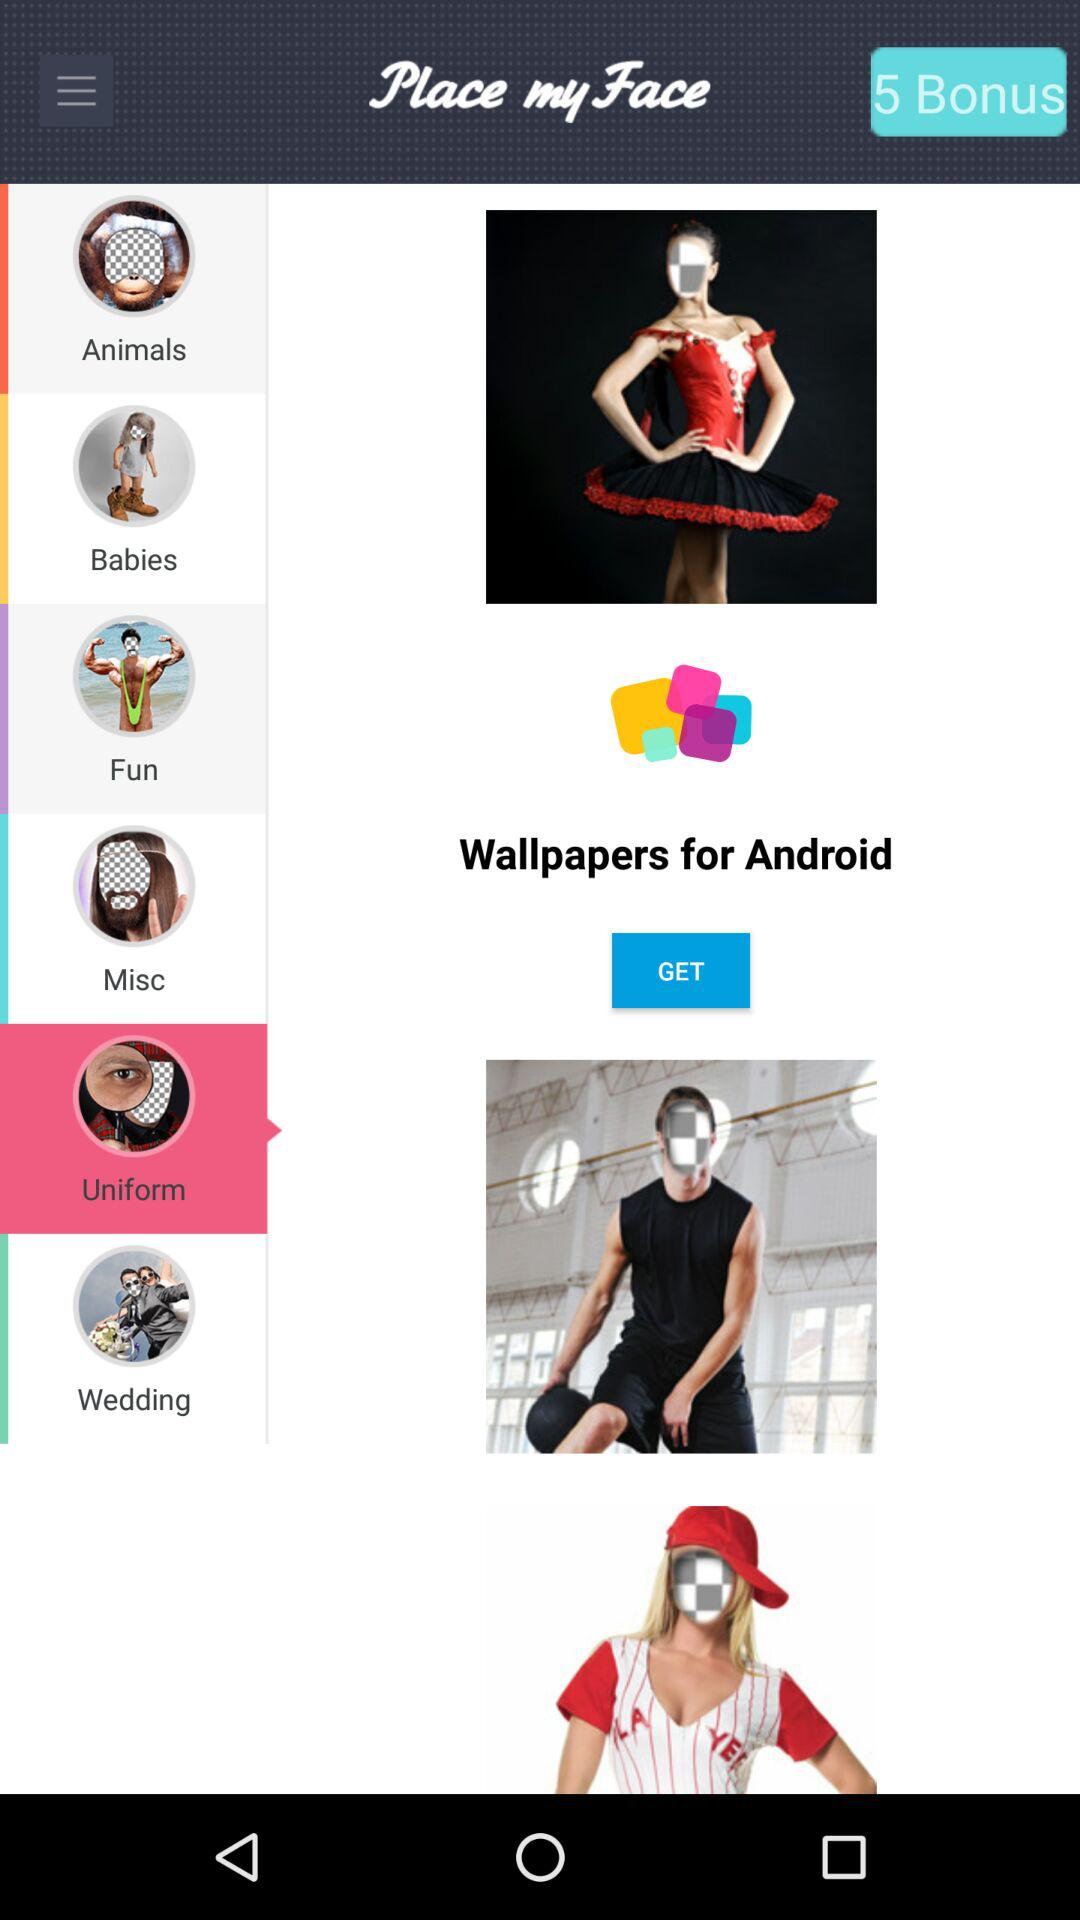What is the number of "Bonus"? The number of "Bonus" is 5. 